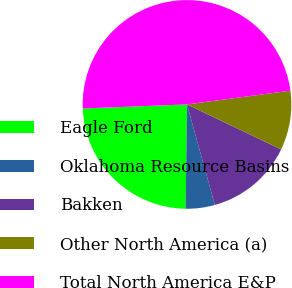Convert chart. <chart><loc_0><loc_0><loc_500><loc_500><pie_chart><fcel>Eagle Ford<fcel>Oklahoma Resource Basins<fcel>Bakken<fcel>Other North America (a)<fcel>Total North America E&P<nl><fcel>24.17%<fcel>4.51%<fcel>13.6%<fcel>9.2%<fcel>48.52%<nl></chart> 